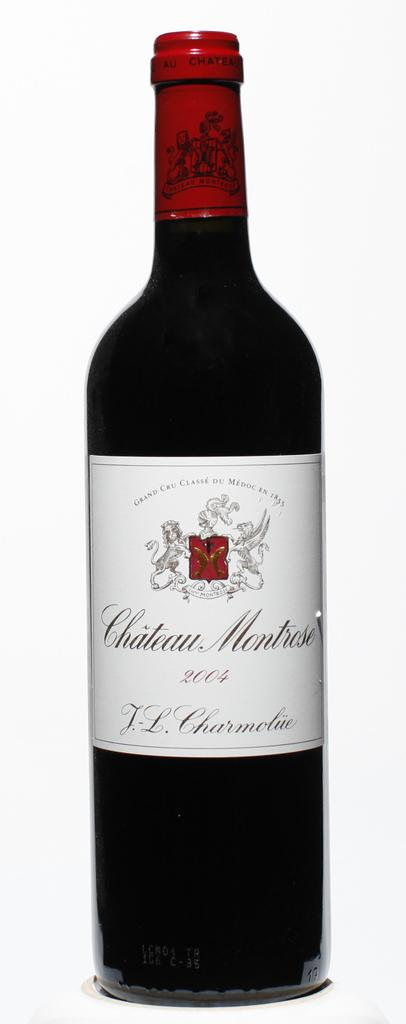<image>
Write a terse but informative summary of the picture. A bottle of Chateau Montrose wine from 2004. 